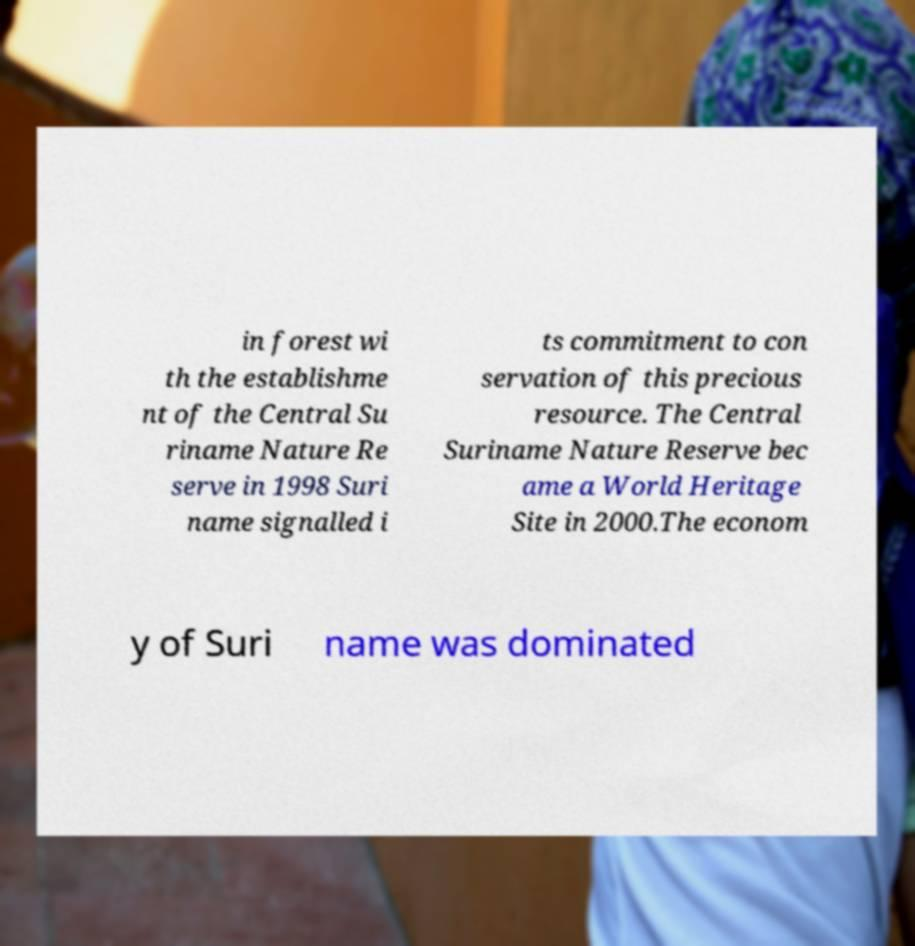What messages or text are displayed in this image? I need them in a readable, typed format. in forest wi th the establishme nt of the Central Su riname Nature Re serve in 1998 Suri name signalled i ts commitment to con servation of this precious resource. The Central Suriname Nature Reserve bec ame a World Heritage Site in 2000.The econom y of Suri name was dominated 